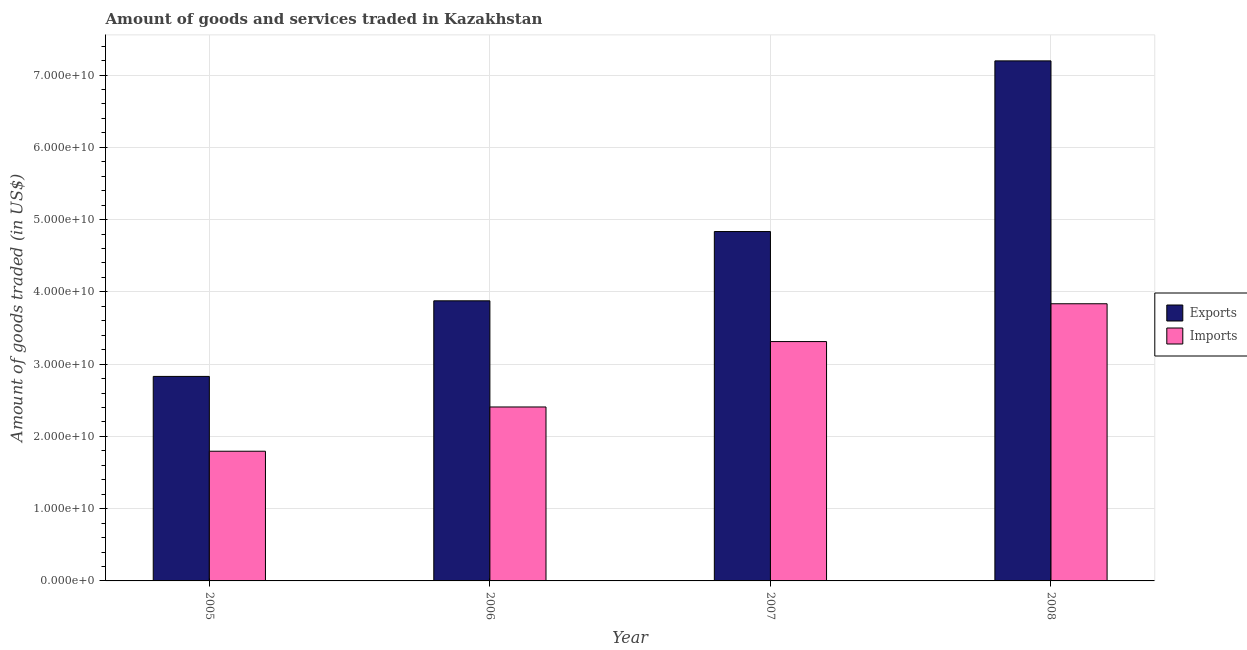How many groups of bars are there?
Your response must be concise. 4. Are the number of bars per tick equal to the number of legend labels?
Give a very brief answer. Yes. What is the label of the 1st group of bars from the left?
Offer a terse response. 2005. In how many cases, is the number of bars for a given year not equal to the number of legend labels?
Offer a very short reply. 0. What is the amount of goods exported in 2006?
Provide a succinct answer. 3.88e+1. Across all years, what is the maximum amount of goods imported?
Your answer should be compact. 3.84e+1. Across all years, what is the minimum amount of goods imported?
Offer a terse response. 1.79e+1. In which year was the amount of goods imported maximum?
Your answer should be compact. 2008. What is the total amount of goods exported in the graph?
Your response must be concise. 1.87e+11. What is the difference between the amount of goods exported in 2005 and that in 2007?
Offer a very short reply. -2.00e+1. What is the difference between the amount of goods imported in 2005 and the amount of goods exported in 2007?
Your response must be concise. -1.52e+1. What is the average amount of goods imported per year?
Ensure brevity in your answer.  2.84e+1. In how many years, is the amount of goods imported greater than 26000000000 US$?
Your answer should be very brief. 2. What is the ratio of the amount of goods imported in 2005 to that in 2006?
Provide a short and direct response. 0.75. What is the difference between the highest and the second highest amount of goods exported?
Offer a very short reply. 2.36e+1. What is the difference between the highest and the lowest amount of goods imported?
Offer a very short reply. 2.04e+1. In how many years, is the amount of goods imported greater than the average amount of goods imported taken over all years?
Keep it short and to the point. 2. What does the 2nd bar from the left in 2008 represents?
Keep it short and to the point. Imports. What does the 1st bar from the right in 2005 represents?
Your response must be concise. Imports. How many years are there in the graph?
Provide a short and direct response. 4. What is the difference between two consecutive major ticks on the Y-axis?
Give a very brief answer. 1.00e+1. Are the values on the major ticks of Y-axis written in scientific E-notation?
Your answer should be very brief. Yes. Does the graph contain any zero values?
Your response must be concise. No. Does the graph contain grids?
Keep it short and to the point. Yes. Where does the legend appear in the graph?
Keep it short and to the point. Center right. How many legend labels are there?
Give a very brief answer. 2. What is the title of the graph?
Your answer should be compact. Amount of goods and services traded in Kazakhstan. What is the label or title of the Y-axis?
Your answer should be compact. Amount of goods traded (in US$). What is the Amount of goods traded (in US$) in Exports in 2005?
Your answer should be compact. 2.83e+1. What is the Amount of goods traded (in US$) of Imports in 2005?
Offer a very short reply. 1.79e+1. What is the Amount of goods traded (in US$) of Exports in 2006?
Provide a short and direct response. 3.88e+1. What is the Amount of goods traded (in US$) in Imports in 2006?
Your answer should be compact. 2.41e+1. What is the Amount of goods traded (in US$) in Exports in 2007?
Provide a succinct answer. 4.83e+1. What is the Amount of goods traded (in US$) of Imports in 2007?
Your answer should be very brief. 3.31e+1. What is the Amount of goods traded (in US$) of Exports in 2008?
Your answer should be compact. 7.20e+1. What is the Amount of goods traded (in US$) of Imports in 2008?
Your answer should be compact. 3.84e+1. Across all years, what is the maximum Amount of goods traded (in US$) of Exports?
Your answer should be compact. 7.20e+1. Across all years, what is the maximum Amount of goods traded (in US$) of Imports?
Ensure brevity in your answer.  3.84e+1. Across all years, what is the minimum Amount of goods traded (in US$) in Exports?
Your response must be concise. 2.83e+1. Across all years, what is the minimum Amount of goods traded (in US$) in Imports?
Provide a succinct answer. 1.79e+1. What is the total Amount of goods traded (in US$) of Exports in the graph?
Offer a terse response. 1.87e+11. What is the total Amount of goods traded (in US$) of Imports in the graph?
Make the answer very short. 1.13e+11. What is the difference between the Amount of goods traded (in US$) in Exports in 2005 and that in 2006?
Provide a succinct answer. -1.05e+1. What is the difference between the Amount of goods traded (in US$) of Imports in 2005 and that in 2006?
Give a very brief answer. -6.12e+09. What is the difference between the Amount of goods traded (in US$) in Exports in 2005 and that in 2007?
Your response must be concise. -2.00e+1. What is the difference between the Amount of goods traded (in US$) in Imports in 2005 and that in 2007?
Make the answer very short. -1.52e+1. What is the difference between the Amount of goods traded (in US$) in Exports in 2005 and that in 2008?
Provide a succinct answer. -4.37e+1. What is the difference between the Amount of goods traded (in US$) of Imports in 2005 and that in 2008?
Your answer should be very brief. -2.04e+1. What is the difference between the Amount of goods traded (in US$) of Exports in 2006 and that in 2007?
Provide a succinct answer. -9.59e+09. What is the difference between the Amount of goods traded (in US$) in Imports in 2006 and that in 2007?
Your answer should be very brief. -9.05e+09. What is the difference between the Amount of goods traded (in US$) in Exports in 2006 and that in 2008?
Offer a very short reply. -3.32e+1. What is the difference between the Amount of goods traded (in US$) of Imports in 2006 and that in 2008?
Ensure brevity in your answer.  -1.43e+1. What is the difference between the Amount of goods traded (in US$) of Exports in 2007 and that in 2008?
Keep it short and to the point. -2.36e+1. What is the difference between the Amount of goods traded (in US$) in Imports in 2007 and that in 2008?
Keep it short and to the point. -5.23e+09. What is the difference between the Amount of goods traded (in US$) of Exports in 2005 and the Amount of goods traded (in US$) of Imports in 2006?
Ensure brevity in your answer.  4.23e+09. What is the difference between the Amount of goods traded (in US$) in Exports in 2005 and the Amount of goods traded (in US$) in Imports in 2007?
Ensure brevity in your answer.  -4.82e+09. What is the difference between the Amount of goods traded (in US$) in Exports in 2005 and the Amount of goods traded (in US$) in Imports in 2008?
Your answer should be compact. -1.01e+1. What is the difference between the Amount of goods traded (in US$) in Exports in 2006 and the Amount of goods traded (in US$) in Imports in 2007?
Offer a terse response. 5.64e+09. What is the difference between the Amount of goods traded (in US$) in Exports in 2006 and the Amount of goods traded (in US$) in Imports in 2008?
Your answer should be compact. 4.07e+08. What is the difference between the Amount of goods traded (in US$) of Exports in 2007 and the Amount of goods traded (in US$) of Imports in 2008?
Offer a very short reply. 9.99e+09. What is the average Amount of goods traded (in US$) of Exports per year?
Your answer should be compact. 4.68e+1. What is the average Amount of goods traded (in US$) in Imports per year?
Ensure brevity in your answer.  2.84e+1. In the year 2005, what is the difference between the Amount of goods traded (in US$) in Exports and Amount of goods traded (in US$) in Imports?
Keep it short and to the point. 1.04e+1. In the year 2006, what is the difference between the Amount of goods traded (in US$) in Exports and Amount of goods traded (in US$) in Imports?
Offer a very short reply. 1.47e+1. In the year 2007, what is the difference between the Amount of goods traded (in US$) in Exports and Amount of goods traded (in US$) in Imports?
Your answer should be very brief. 1.52e+1. In the year 2008, what is the difference between the Amount of goods traded (in US$) of Exports and Amount of goods traded (in US$) of Imports?
Your response must be concise. 3.36e+1. What is the ratio of the Amount of goods traded (in US$) in Exports in 2005 to that in 2006?
Keep it short and to the point. 0.73. What is the ratio of the Amount of goods traded (in US$) in Imports in 2005 to that in 2006?
Offer a very short reply. 0.75. What is the ratio of the Amount of goods traded (in US$) of Exports in 2005 to that in 2007?
Give a very brief answer. 0.59. What is the ratio of the Amount of goods traded (in US$) in Imports in 2005 to that in 2007?
Make the answer very short. 0.54. What is the ratio of the Amount of goods traded (in US$) of Exports in 2005 to that in 2008?
Make the answer very short. 0.39. What is the ratio of the Amount of goods traded (in US$) of Imports in 2005 to that in 2008?
Provide a succinct answer. 0.47. What is the ratio of the Amount of goods traded (in US$) of Exports in 2006 to that in 2007?
Your answer should be very brief. 0.8. What is the ratio of the Amount of goods traded (in US$) of Imports in 2006 to that in 2007?
Give a very brief answer. 0.73. What is the ratio of the Amount of goods traded (in US$) of Exports in 2006 to that in 2008?
Ensure brevity in your answer.  0.54. What is the ratio of the Amount of goods traded (in US$) of Imports in 2006 to that in 2008?
Your answer should be compact. 0.63. What is the ratio of the Amount of goods traded (in US$) in Exports in 2007 to that in 2008?
Your answer should be compact. 0.67. What is the ratio of the Amount of goods traded (in US$) in Imports in 2007 to that in 2008?
Offer a very short reply. 0.86. What is the difference between the highest and the second highest Amount of goods traded (in US$) of Exports?
Offer a very short reply. 2.36e+1. What is the difference between the highest and the second highest Amount of goods traded (in US$) of Imports?
Make the answer very short. 5.23e+09. What is the difference between the highest and the lowest Amount of goods traded (in US$) of Exports?
Provide a succinct answer. 4.37e+1. What is the difference between the highest and the lowest Amount of goods traded (in US$) of Imports?
Offer a terse response. 2.04e+1. 